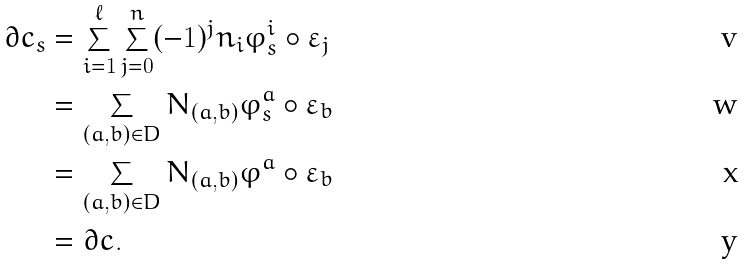<formula> <loc_0><loc_0><loc_500><loc_500>\partial c _ { s } & = \sum _ { i = 1 } ^ { \ell } \sum _ { j = 0 } ^ { n } ( - 1 ) ^ { j } n _ { i } \varphi ^ { i } _ { s } \circ \varepsilon _ { j } \\ & = \sum _ { ( a , b ) \in D } N _ { ( a , b ) } \varphi ^ { a } _ { s } \circ \varepsilon _ { b } \\ & = \sum _ { ( a , b ) \in D } N _ { ( a , b ) } \varphi ^ { a } \circ \varepsilon _ { b } \\ & = \partial c .</formula> 